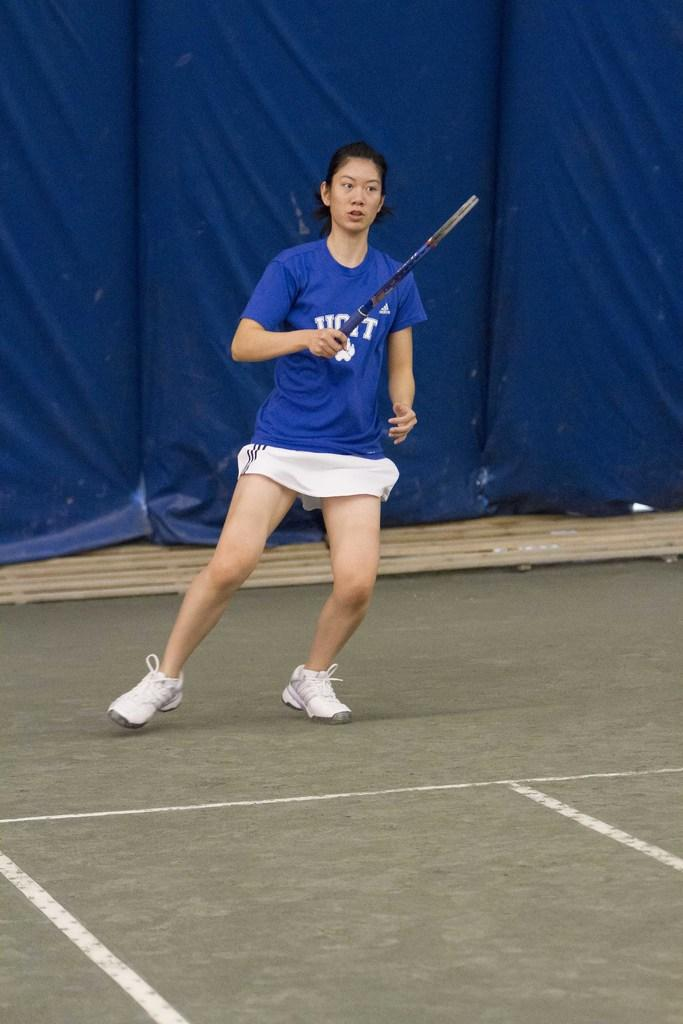What is the main subject of the image? There is a person standing in the image. What is the person holding in her hand? The person is holding a racket in her hand. What color is the t-shirt the person is wearing? The person is wearing a blue t-shirt. What can be seen behind the person in the image? There are blue curtains behind the person. What type of station is visible in the background of the image? There is no station visible in the background of the image; it features a person holding a racket and blue curtains. What is the condition of the person's wrist in the image? There is no information about the person's wrist in the image, as the focus is on the person holding a racket and wearing a blue t-shirt. 